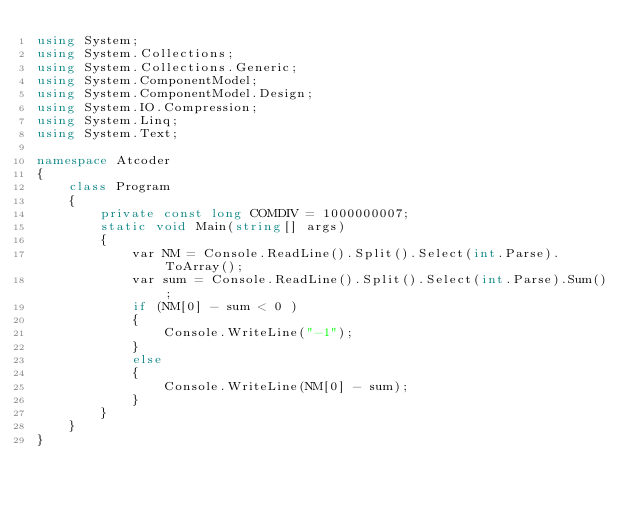Convert code to text. <code><loc_0><loc_0><loc_500><loc_500><_C#_>using System;
using System.Collections;
using System.Collections.Generic;
using System.ComponentModel;
using System.ComponentModel.Design;
using System.IO.Compression;
using System.Linq;
using System.Text;

namespace Atcoder
{
    class Program
    {
        private const long COMDIV = 1000000007;
        static void Main(string[] args)
        {
            var NM = Console.ReadLine().Split().Select(int.Parse).ToArray();
            var sum = Console.ReadLine().Split().Select(int.Parse).Sum();
            if (NM[0] - sum < 0 )
            {
                Console.WriteLine("-1");
            }
            else
            {
                Console.WriteLine(NM[0] - sum);
            }
        }
    }
}</code> 